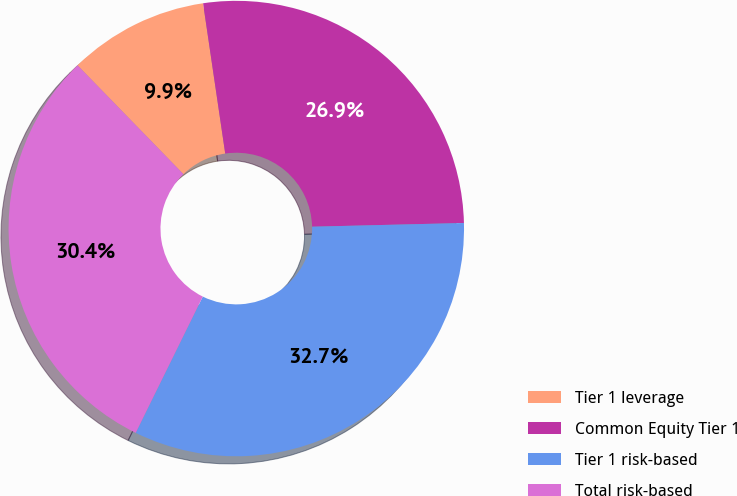Convert chart. <chart><loc_0><loc_0><loc_500><loc_500><pie_chart><fcel>Tier 1 leverage<fcel>Common Equity Tier 1<fcel>Tier 1 risk-based<fcel>Total risk-based<nl><fcel>9.95%<fcel>26.94%<fcel>32.67%<fcel>30.44%<nl></chart> 